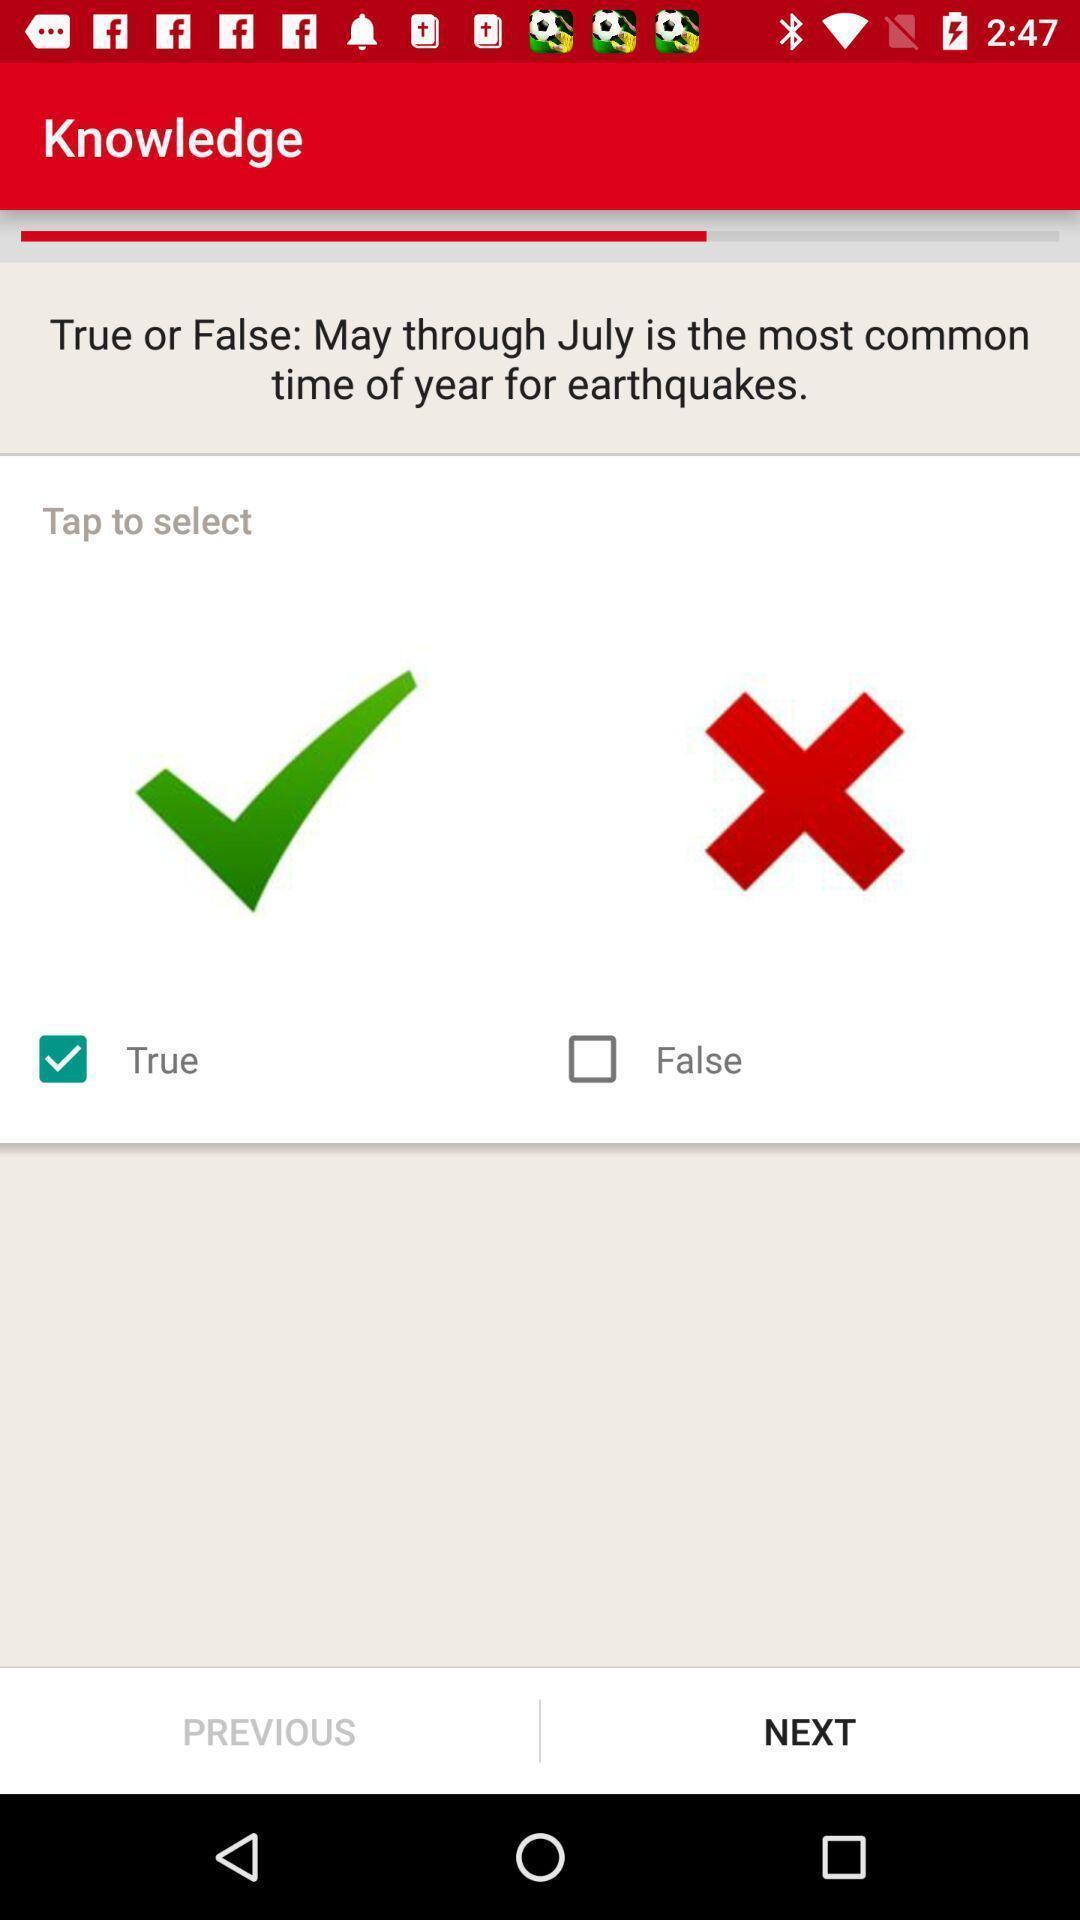Summarize the information in this screenshot. Screen displaying options to answer the question in knowledge page. 